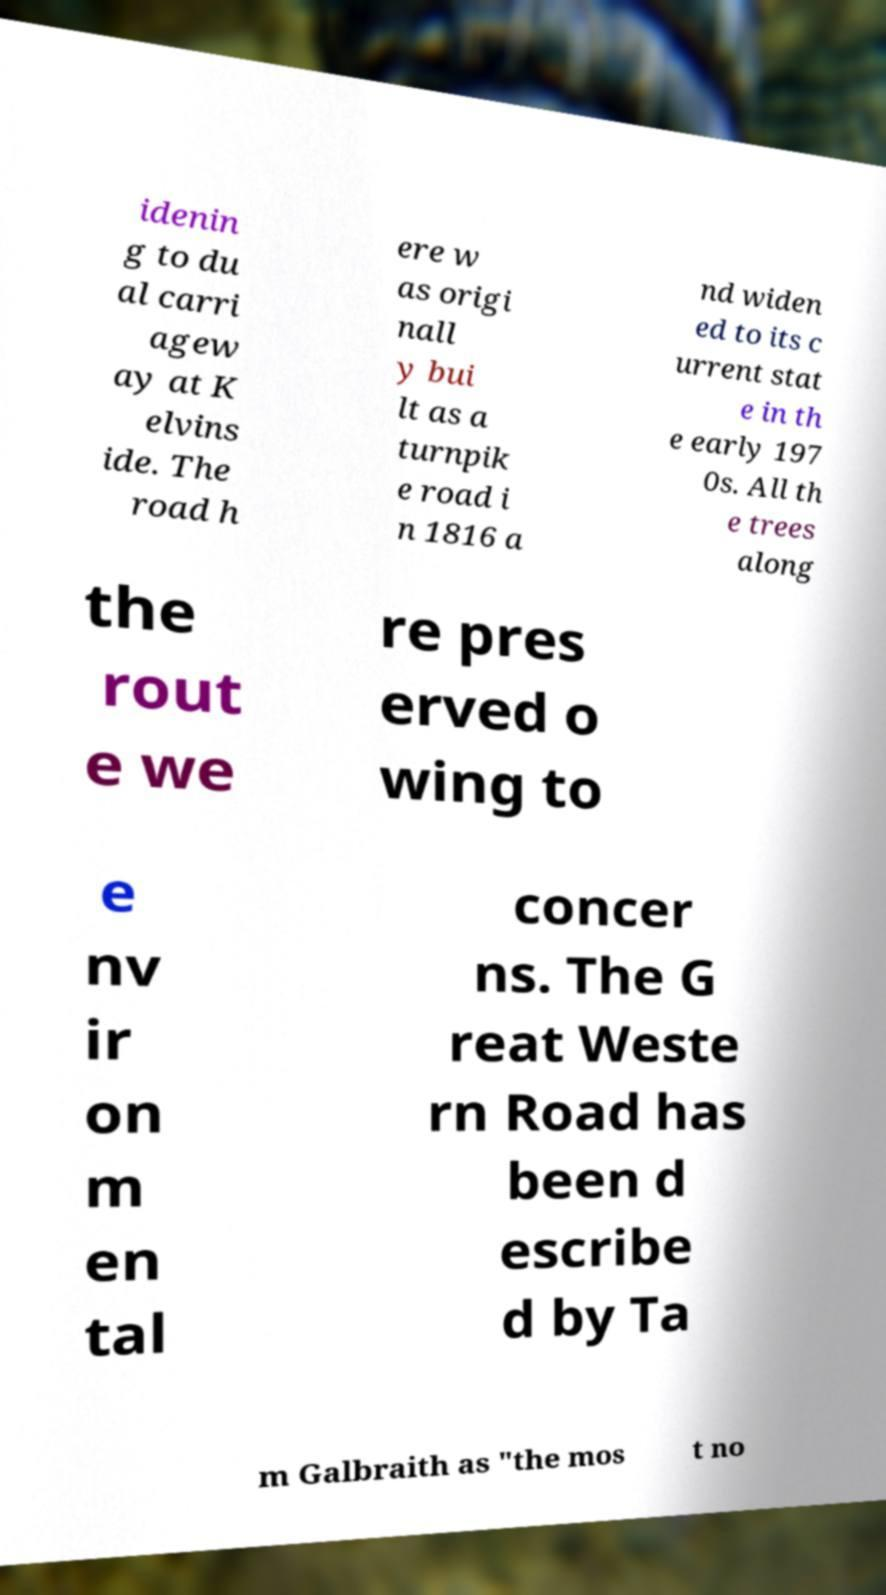Can you accurately transcribe the text from the provided image for me? idenin g to du al carri agew ay at K elvins ide. The road h ere w as origi nall y bui lt as a turnpik e road i n 1816 a nd widen ed to its c urrent stat e in th e early 197 0s. All th e trees along the rout e we re pres erved o wing to e nv ir on m en tal concer ns. The G reat Weste rn Road has been d escribe d by Ta m Galbraith as "the mos t no 